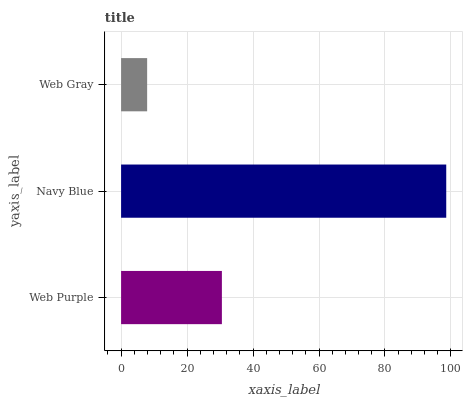Is Web Gray the minimum?
Answer yes or no. Yes. Is Navy Blue the maximum?
Answer yes or no. Yes. Is Navy Blue the minimum?
Answer yes or no. No. Is Web Gray the maximum?
Answer yes or no. No. Is Navy Blue greater than Web Gray?
Answer yes or no. Yes. Is Web Gray less than Navy Blue?
Answer yes or no. Yes. Is Web Gray greater than Navy Blue?
Answer yes or no. No. Is Navy Blue less than Web Gray?
Answer yes or no. No. Is Web Purple the high median?
Answer yes or no. Yes. Is Web Purple the low median?
Answer yes or no. Yes. Is Navy Blue the high median?
Answer yes or no. No. Is Web Gray the low median?
Answer yes or no. No. 